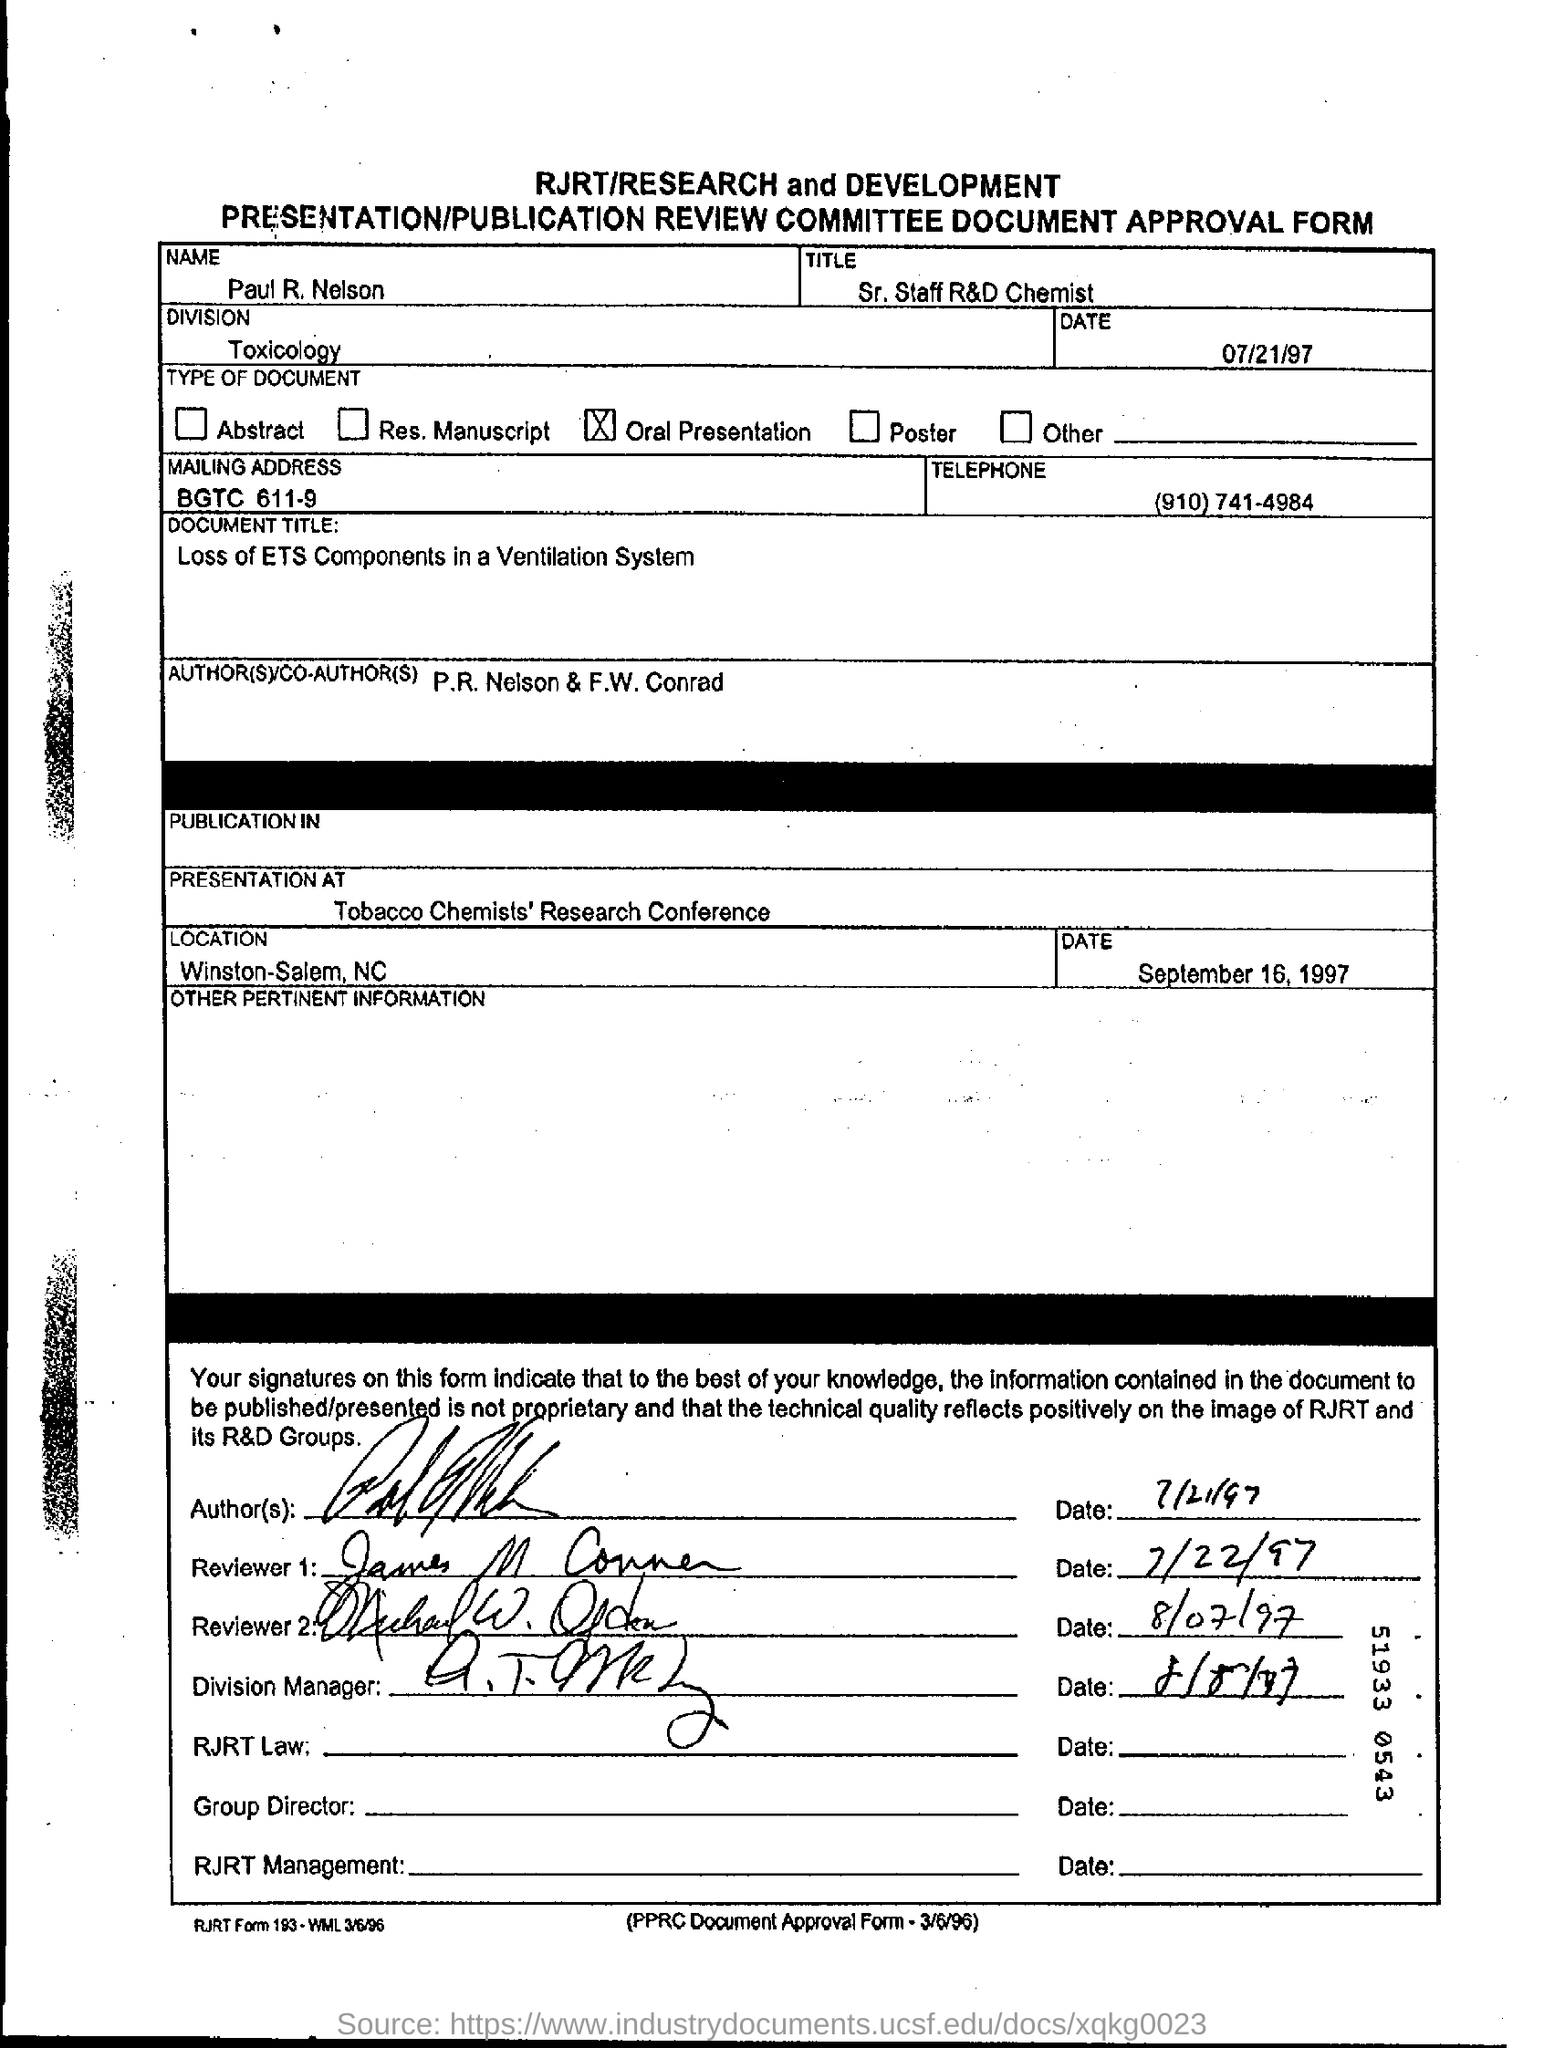What is the title mentioned
Offer a very short reply. Sr . staff r&d chemist. What is the date mentioned ?
Provide a short and direct response. September16 , 1997. What is the mailing address?
Make the answer very short. BGTC 611-9. What is the telephone number ?
Make the answer very short. (910)741-4984. Where did the presentation took place ?
Offer a very short reply. Tobacco Chemists' Research Conference. 